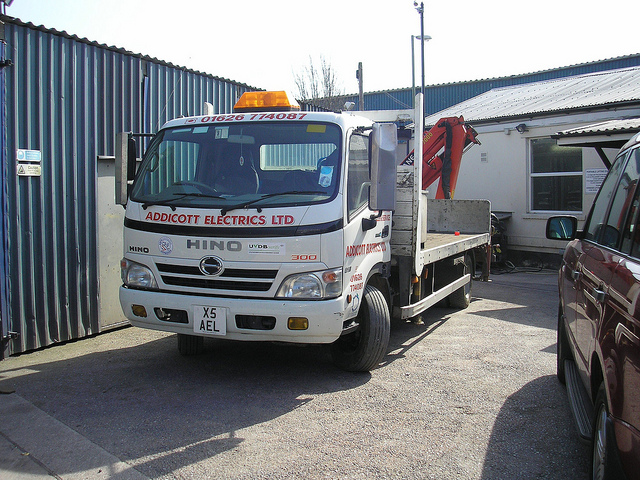Identify the text contained in this image. ADDICOTT HINO ELECTRICS 774087 LTD 01626 AEL 